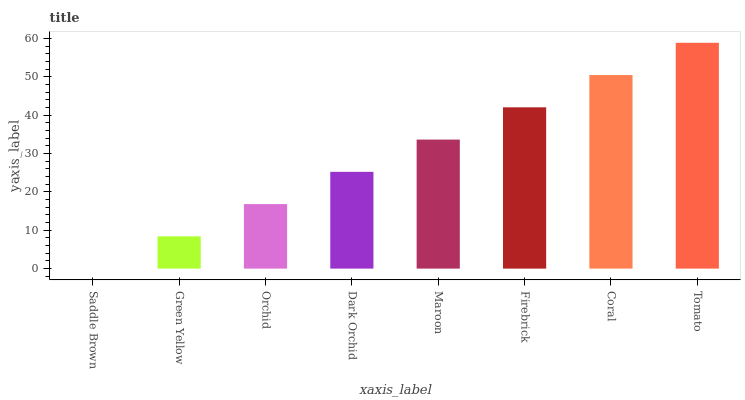Is Green Yellow the minimum?
Answer yes or no. No. Is Green Yellow the maximum?
Answer yes or no. No. Is Green Yellow greater than Saddle Brown?
Answer yes or no. Yes. Is Saddle Brown less than Green Yellow?
Answer yes or no. Yes. Is Saddle Brown greater than Green Yellow?
Answer yes or no. No. Is Green Yellow less than Saddle Brown?
Answer yes or no. No. Is Maroon the high median?
Answer yes or no. Yes. Is Dark Orchid the low median?
Answer yes or no. Yes. Is Dark Orchid the high median?
Answer yes or no. No. Is Maroon the low median?
Answer yes or no. No. 